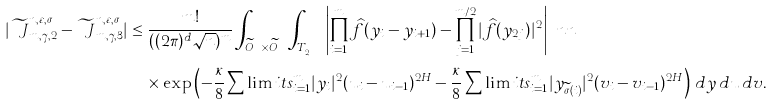<formula> <loc_0><loc_0><loc_500><loc_500>| \widetilde { \ J } ^ { n , \varepsilon , \sigma } _ { m , \gamma , 2 } - \widetilde { \ J } ^ { n , \varepsilon , \sigma } _ { m , \gamma , 3 } | & \leq \frac { m ! } { ( ( 2 \pi ) ^ { d } \sqrt { n } ) ^ { m } } \int _ { \widetilde { O } ^ { \gamma } _ { m } \times \widetilde { O } ^ { \gamma } _ { m } } \int _ { T ^ { \sigma } _ { \varepsilon , 2 , \gamma } } \left | \prod ^ { m } _ { i = 1 } \widehat { f } ( y _ { i } - y _ { i + 1 } ) - \prod ^ { m / 2 } _ { j = 1 } | \widehat { f } ( y _ { 2 j } ) | ^ { 2 } \right | \ n n \\ & \quad \times \exp \left ( - \frac { \kappa } { 8 } \sum \lim i t s ^ { m } _ { i = 1 } | y _ { i } | ^ { 2 } ( u _ { i } - u _ { i - 1 } ) ^ { 2 H } - \frac { \kappa } { 8 } \sum \lim i t s ^ { m } _ { i = 1 } | y _ { \widetilde { \sigma } ( i ) } | ^ { 2 } ( v _ { i } - v _ { i - 1 } ) ^ { 2 H } \right ) \, d y \, d u \, d v .</formula> 